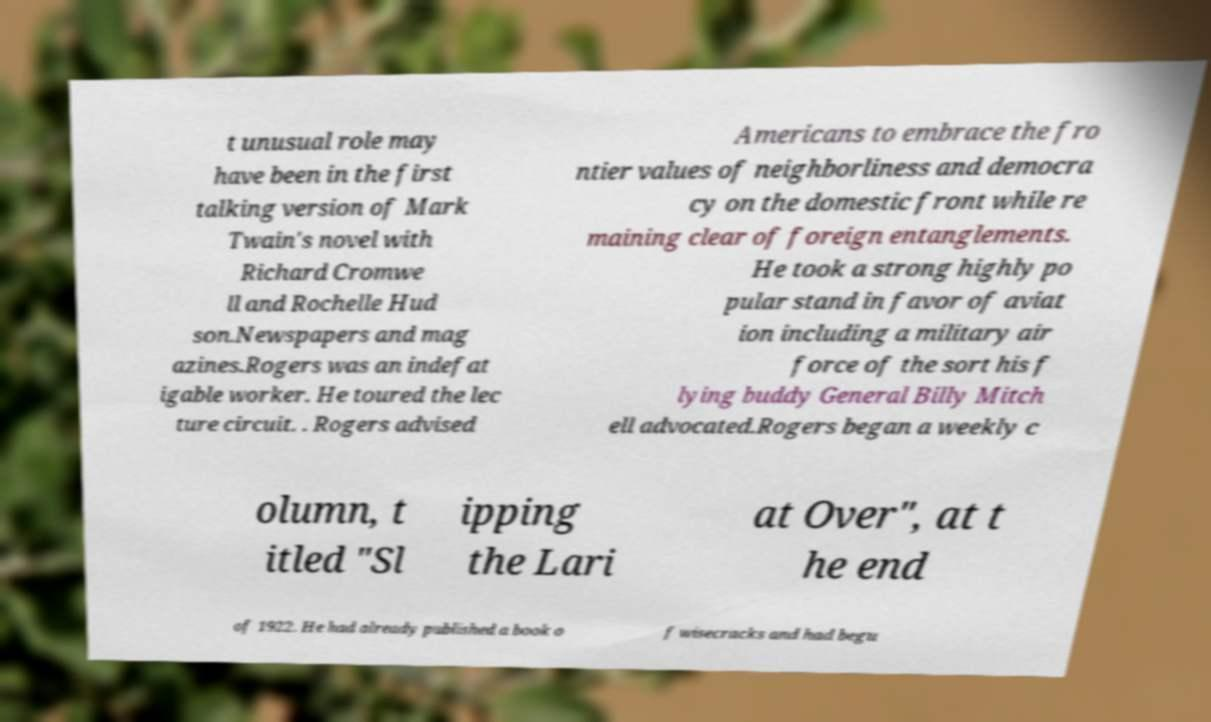Please identify and transcribe the text found in this image. t unusual role may have been in the first talking version of Mark Twain's novel with Richard Cromwe ll and Rochelle Hud son.Newspapers and mag azines.Rogers was an indefat igable worker. He toured the lec ture circuit. . Rogers advised Americans to embrace the fro ntier values of neighborliness and democra cy on the domestic front while re maining clear of foreign entanglements. He took a strong highly po pular stand in favor of aviat ion including a military air force of the sort his f lying buddy General Billy Mitch ell advocated.Rogers began a weekly c olumn, t itled "Sl ipping the Lari at Over", at t he end of 1922. He had already published a book o f wisecracks and had begu 